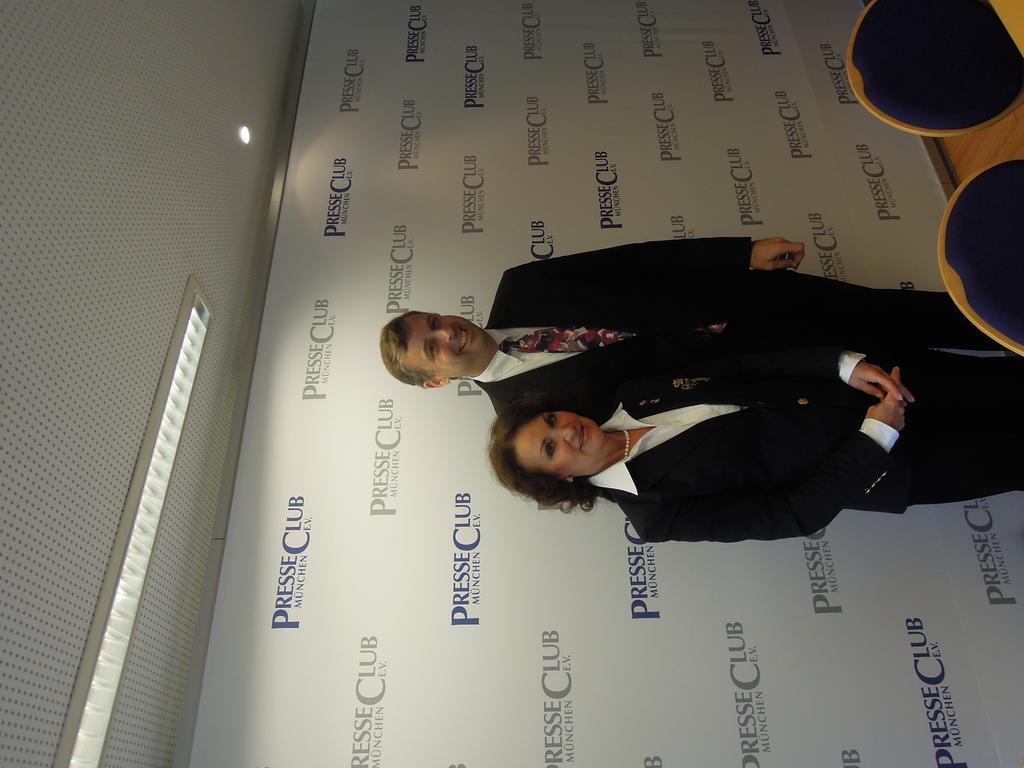Please provide a concise description of this image. In this picture I can see a woman and a man who are standing and I see that they're wearing formal dress and I see that both of them are smiling. On the right side of this picture I can see the chairs. Behind them I can see a board on which there are words written. On the left side of this picture I can see the ceiling on which there are lights. 